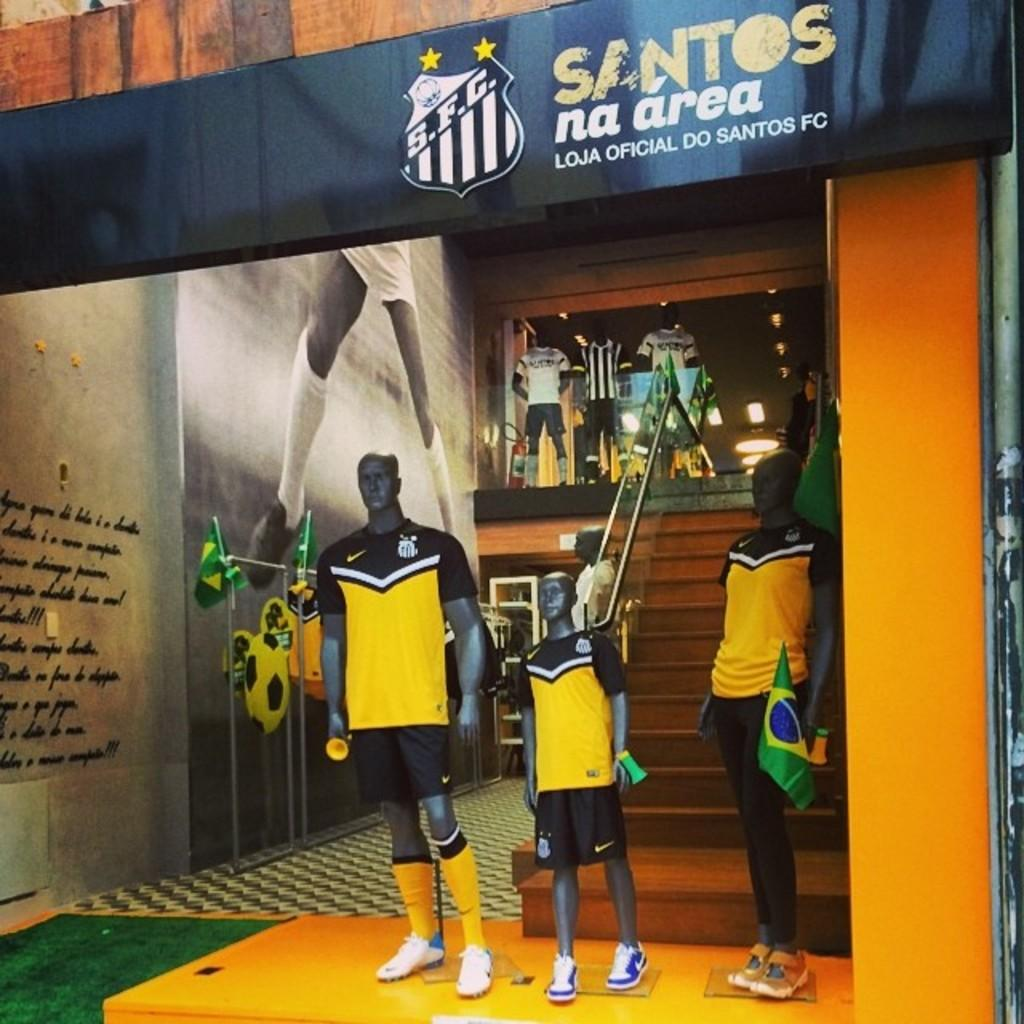What type of store is shown in the image? There is a sports equipment store in the image. Can you identify any specific details about the store? A Brazil flag is present in the image. Who is holding the Brazil flag? The Brazil flag is held by a mannequin. Where is the mannequin located in relation to the store? The mannequin is standing in front of the store. What color are the mannequin's eyes in the image? The image does not show the mannequin's eyes, so we cannot determine their color. 